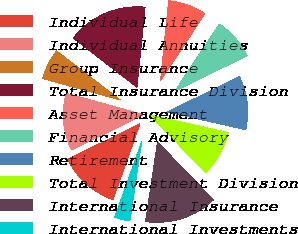<chart> <loc_0><loc_0><loc_500><loc_500><pie_chart><fcel>Individual Life<fcel>Individual Annuities<fcel>Group Insurance<fcel>Total Insurance Division<fcel>Asset Management<fcel>Financial Advisory<fcel>Retirement<fcel>Total Investment Division<fcel>International Insurance<fcel>International Investments<nl><fcel>12.31%<fcel>11.54%<fcel>6.16%<fcel>16.15%<fcel>7.69%<fcel>8.46%<fcel>10.77%<fcel>9.23%<fcel>14.61%<fcel>3.08%<nl></chart> 